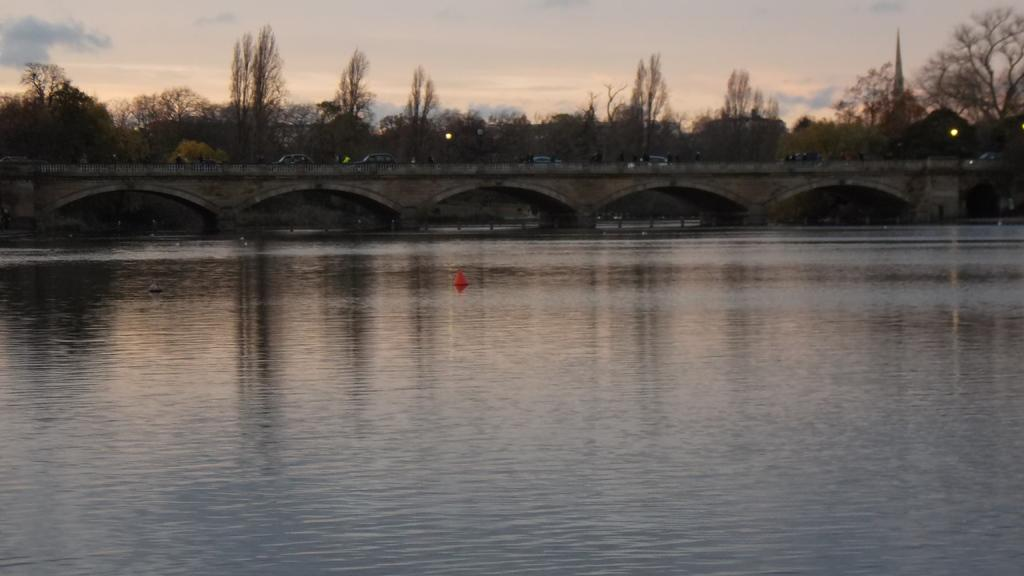What is the main structure in the center of the image? There is a bridge in the center of the image. What is happening on the bridge? Vehicles are present on the bridge. What can be seen in the background of the image? There are trees and the sky visible in the background of the image. What is at the bottom of the image? There is water at the bottom of the image. How many passengers are on the tree in the image? There are no passengers on a tree in the image, as trees do not have passengers. 